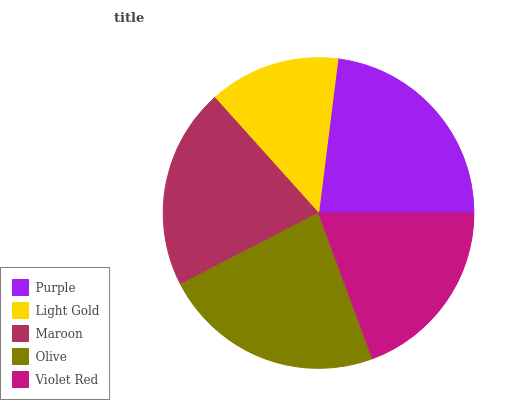Is Light Gold the minimum?
Answer yes or no. Yes. Is Olive the maximum?
Answer yes or no. Yes. Is Maroon the minimum?
Answer yes or no. No. Is Maroon the maximum?
Answer yes or no. No. Is Maroon greater than Light Gold?
Answer yes or no. Yes. Is Light Gold less than Maroon?
Answer yes or no. Yes. Is Light Gold greater than Maroon?
Answer yes or no. No. Is Maroon less than Light Gold?
Answer yes or no. No. Is Maroon the high median?
Answer yes or no. Yes. Is Maroon the low median?
Answer yes or no. Yes. Is Light Gold the high median?
Answer yes or no. No. Is Violet Red the low median?
Answer yes or no. No. 